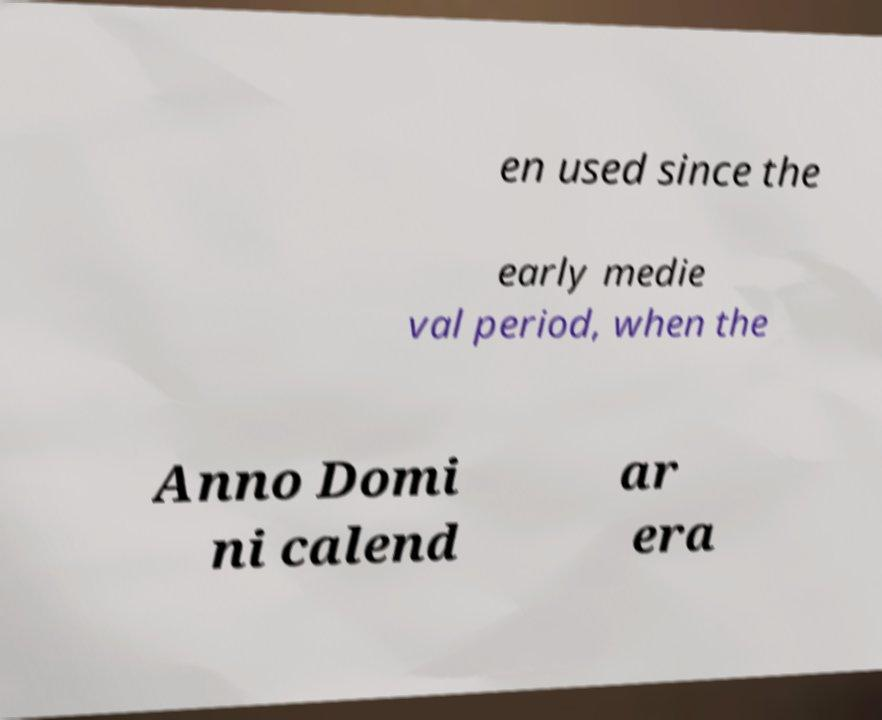Can you accurately transcribe the text from the provided image for me? en used since the early medie val period, when the Anno Domi ni calend ar era 